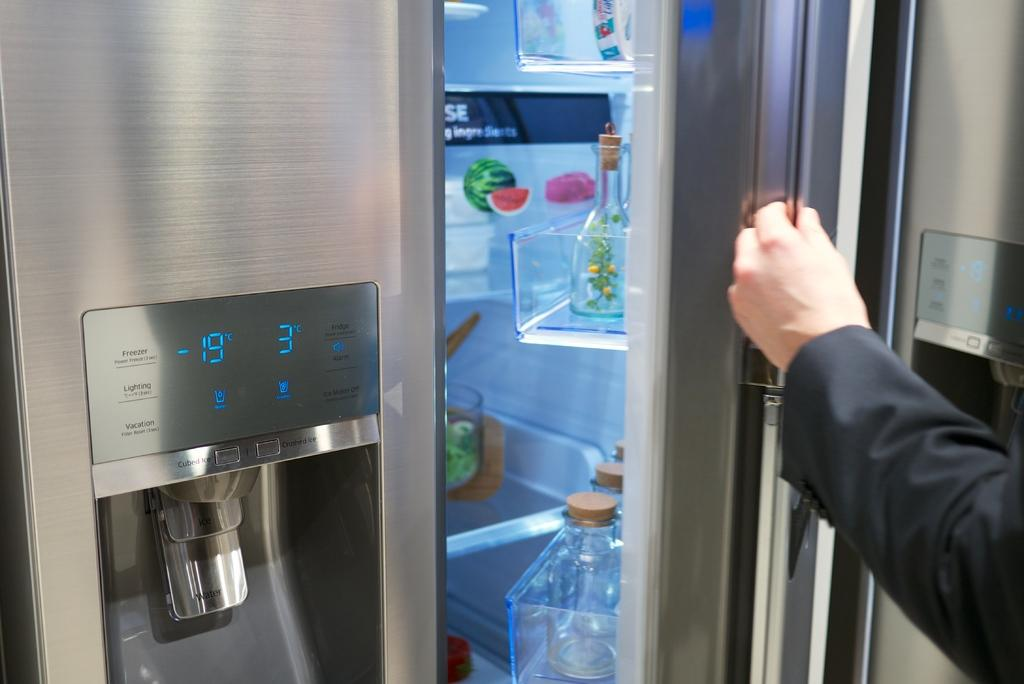<image>
Write a terse but informative summary of the picture. A refrigerator door reads -19 and 3 degrees above the dispenser. 